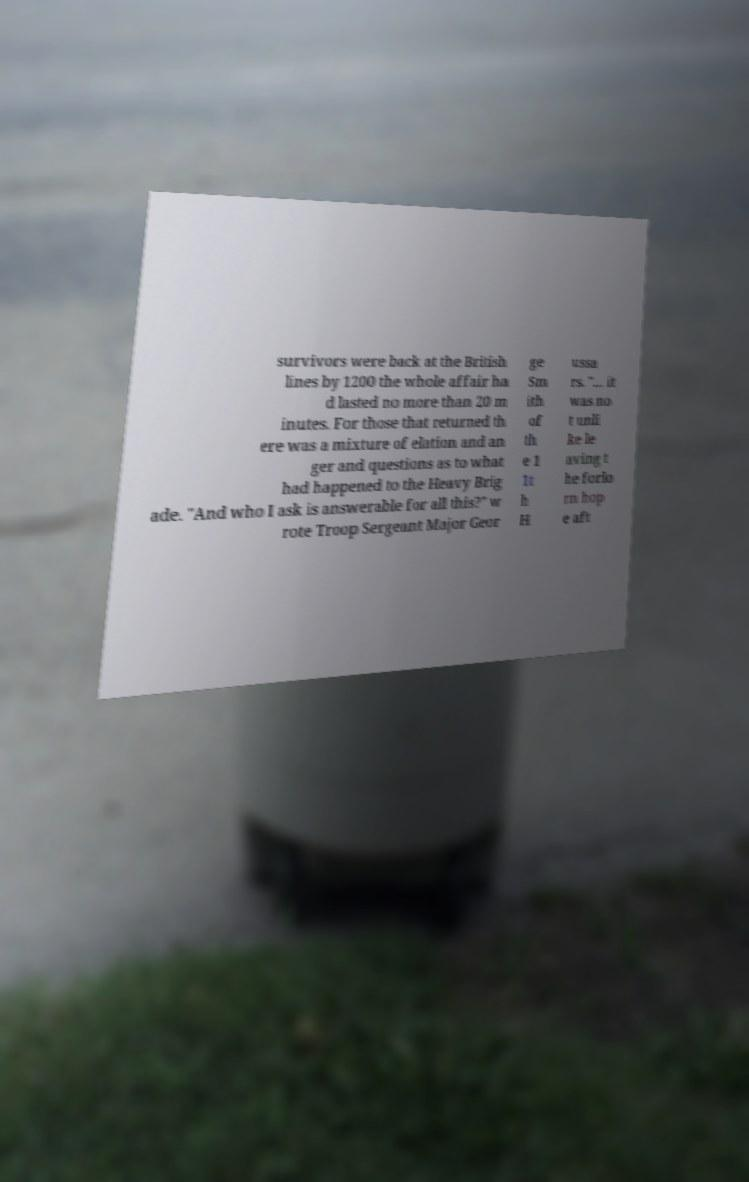Please read and relay the text visible in this image. What does it say? survivors were back at the British lines by 1200 the whole affair ha d lasted no more than 20 m inutes. For those that returned th ere was a mixture of elation and an ger and questions as to what had happened to the Heavy Brig ade. "And who I ask is answerable for all this?" w rote Troop Sergeant Major Geor ge Sm ith of th e 1 1t h H ussa rs. "… it was no t unli ke le aving t he forlo rn hop e aft 